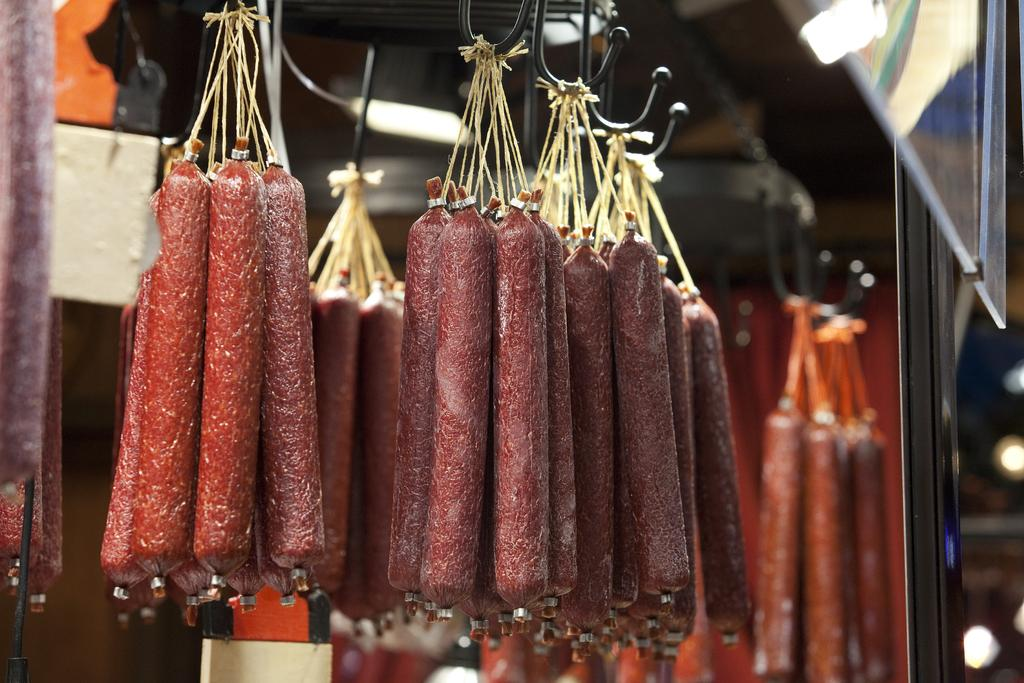What is hanging on the metal rods in the image? Sausages are hanged on metal rods in the image. What can be seen in the background of the image? There is a wall, lights, and a door in the background of the image. Can you describe the setting where the image might have been taken? The image may have been taken in a restaurant, given the presence of sausages and the possible commercial setting. What type of pain can be seen on the faces of the sausages in the image? There is no indication of pain on the faces of the sausages, as sausages do not have faces or the ability to experience pain. 